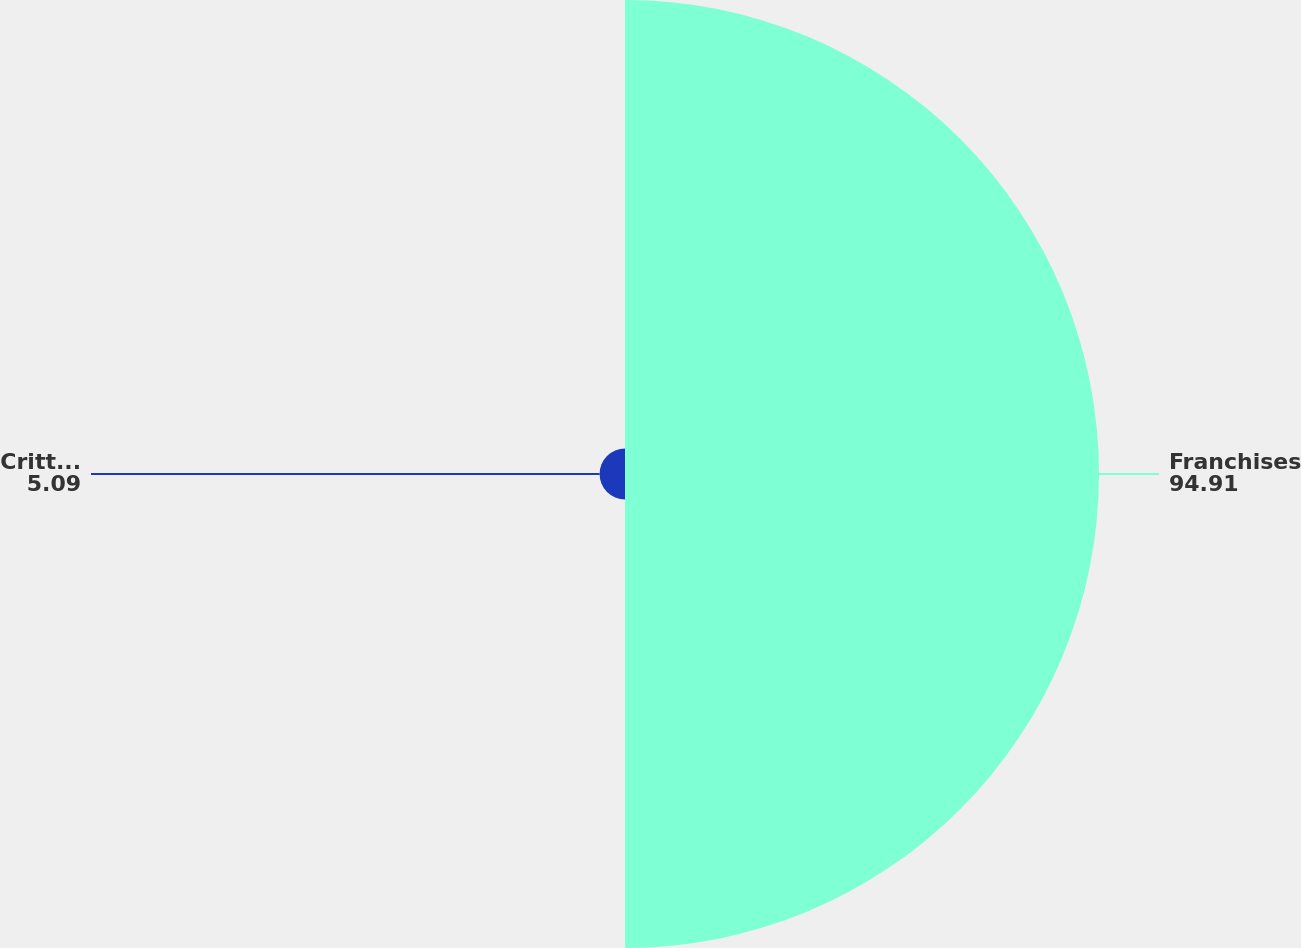Convert chart to OTSL. <chart><loc_0><loc_0><loc_500><loc_500><pie_chart><fcel>Franchises<fcel>Critter Control Franchises<nl><fcel>94.91%<fcel>5.09%<nl></chart> 